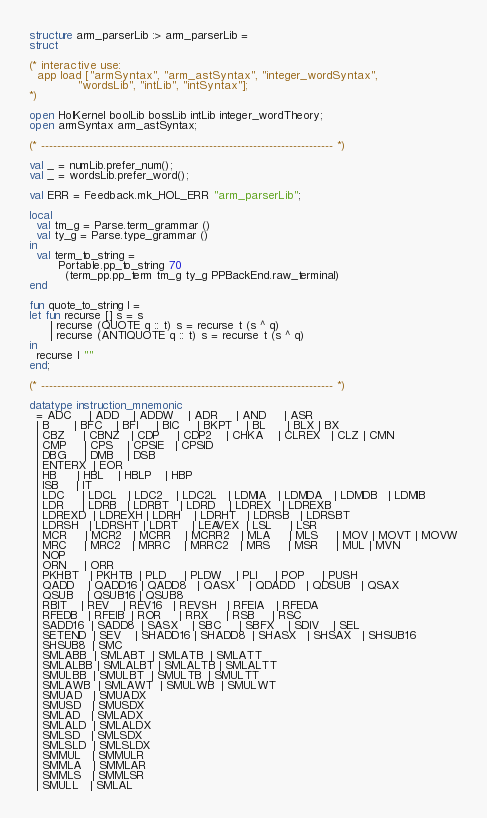<code> <loc_0><loc_0><loc_500><loc_500><_SML_>structure arm_parserLib :> arm_parserLib =
struct

(* interactive use:
  app load ["armSyntax", "arm_astSyntax", "integer_wordSyntax",
            "wordsLib", "intLib", "intSyntax"];
*)

open HolKernel boolLib bossLib intLib integer_wordTheory;
open armSyntax arm_astSyntax;

(* ------------------------------------------------------------------------- *)

val _ = numLib.prefer_num();
val _ = wordsLib.prefer_word();

val ERR = Feedback.mk_HOL_ERR "arm_parserLib";

local
  val tm_g = Parse.term_grammar ()
  val ty_g = Parse.type_grammar ()
in
  val term_to_string =
        Portable.pp_to_string 70
          (term_pp.pp_term tm_g ty_g PPBackEnd.raw_terminal)
end

fun quote_to_string l =
let fun recurse [] s = s
      | recurse (QUOTE q :: t) s = recurse t (s ^ q)
      | recurse (ANTIQUOTE q :: t) s = recurse t (s ^ q)
in
  recurse l ""
end;

(* ------------------------------------------------------------------------- *)

datatype instruction_mnemonic
  = ADC     | ADD    | ADDW    | ADR     | AND     | ASR
  | B       | BFC    | BFI     | BIC     | BKPT    | BL      | BLX | BX
  | CBZ     | CBNZ   | CDP     | CDP2    | CHKA    | CLREX   | CLZ | CMN
  | CMP     | CPS    | CPSIE   | CPSID
  | DBG     | DMB    | DSB
  | ENTERX  | EOR
  | HB      | HBL    | HBLP    | HBP
  | ISB     | IT
  | LDC     | LDCL   | LDC2    | LDC2L   | LDMIA   | LDMDA   | LDMDB   | LDMIB
  | LDR     | LDRB   | LDRBT   | LDRD    | LDREX   | LDREXB
  | LDREXD  | LDREXH | LDRH    | LDRHT   | LDRSB   | LDRSBT
  | LDRSH   | LDRSHT | LDRT    | LEAVEX  | LSL     | LSR
  | MCR     | MCR2   | MCRR    | MCRR2   | MLA     | MLS     | MOV | MOVT | MOVW
  | MRC     | MRC2   | MRRC    | MRRC2   | MRS     | MSR     | MUL | MVN
  | NOP
  | ORN     | ORR
  | PKHBT   | PKHTB  | PLD     | PLDW    | PLI     | POP     | PUSH
  | QADD    | QADD16 | QADD8   | QASX    | QDADD   | QDSUB   | QSAX
  | QSUB    | QSUB16 | QSUB8
  | RBIT    | REV    | REV16   | REVSH   | RFEIA   | RFEDA
  | RFEDB   | RFEIB  | ROR     | RRX     | RSB     | RSC
  | SADD16  | SADD8  | SASX    | SBC     | SBFX    | SDIV    | SEL
  | SETEND  | SEV    | SHADD16 | SHADD8  | SHASX   | SHSAX   | SHSUB16
  | SHSUB8  | SMC
  | SMLABB  | SMLABT  | SMLATB  | SMLATT
  | SMLALBB | SMLALBT | SMLALTB | SMLALTT
  | SMULBB  | SMULBT  | SMULTB  | SMULTT
  | SMLAWB  | SMLAWT  | SMULWB  | SMULWT
  | SMUAD   | SMUADX
  | SMUSD   | SMUSDX
  | SMLAD   | SMLADX
  | SMLALD  | SMLALDX
  | SMLSD   | SMLSDX
  | SMLSLD  | SMLSLDX
  | SMMUL   | SMMULR
  | SMMLA   | SMMLAR
  | SMMLS   | SMMLSR
  | SMULL   | SMLAL</code> 